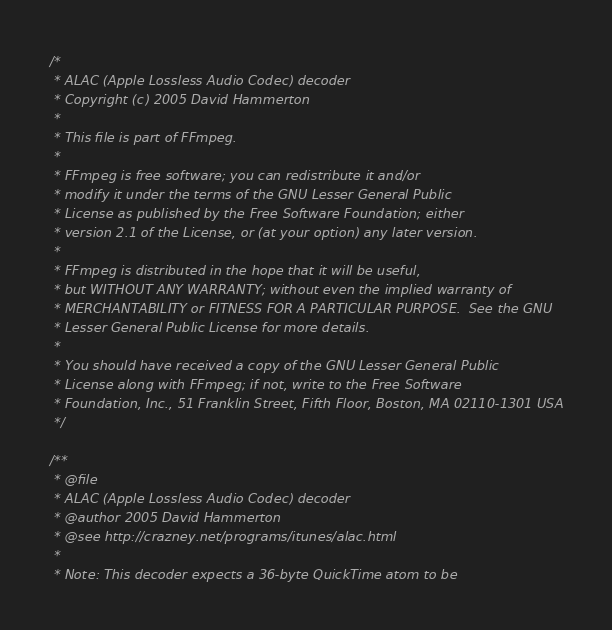<code> <loc_0><loc_0><loc_500><loc_500><_C_>/*
 * ALAC (Apple Lossless Audio Codec) decoder
 * Copyright (c) 2005 David Hammerton
 *
 * This file is part of FFmpeg.
 *
 * FFmpeg is free software; you can redistribute it and/or
 * modify it under the terms of the GNU Lesser General Public
 * License as published by the Free Software Foundation; either
 * version 2.1 of the License, or (at your option) any later version.
 *
 * FFmpeg is distributed in the hope that it will be useful,
 * but WITHOUT ANY WARRANTY; without even the implied warranty of
 * MERCHANTABILITY or FITNESS FOR A PARTICULAR PURPOSE.  See the GNU
 * Lesser General Public License for more details.
 *
 * You should have received a copy of the GNU Lesser General Public
 * License along with FFmpeg; if not, write to the Free Software
 * Foundation, Inc., 51 Franklin Street, Fifth Floor, Boston, MA 02110-1301 USA
 */

/**
 * @file
 * ALAC (Apple Lossless Audio Codec) decoder
 * @author 2005 David Hammerton
 * @see http://crazney.net/programs/itunes/alac.html
 *
 * Note: This decoder expects a 36-byte QuickTime atom to be</code> 